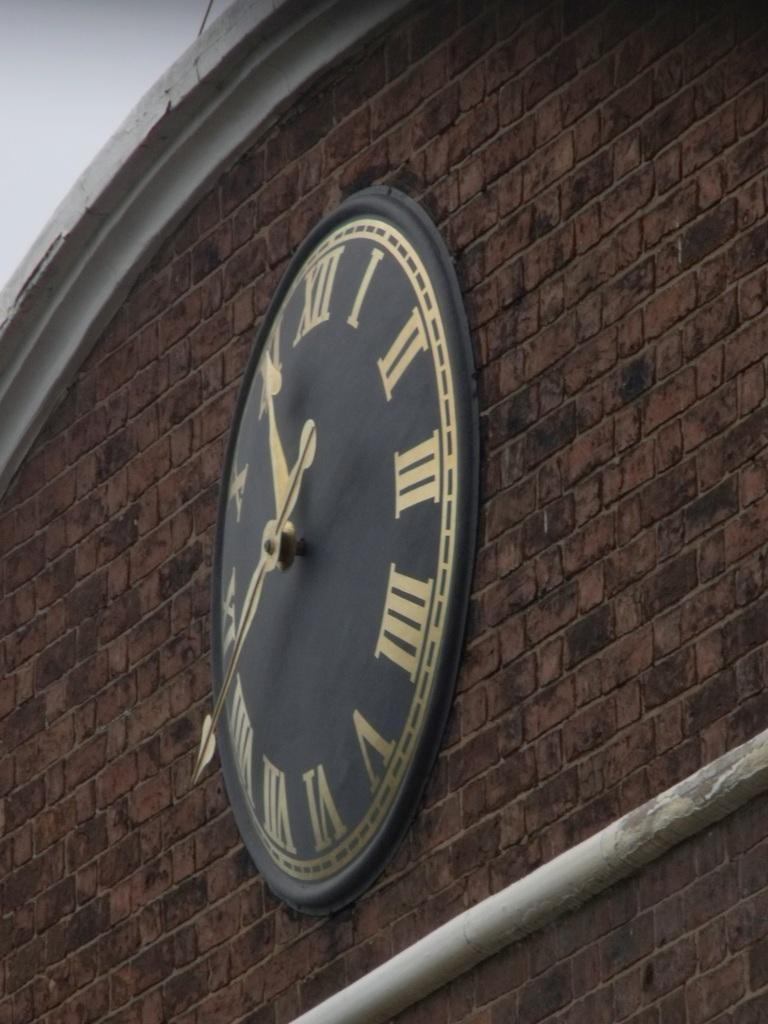<image>
Relay a brief, clear account of the picture shown. A clock that is in roman numerals such as I II XII and VI. 